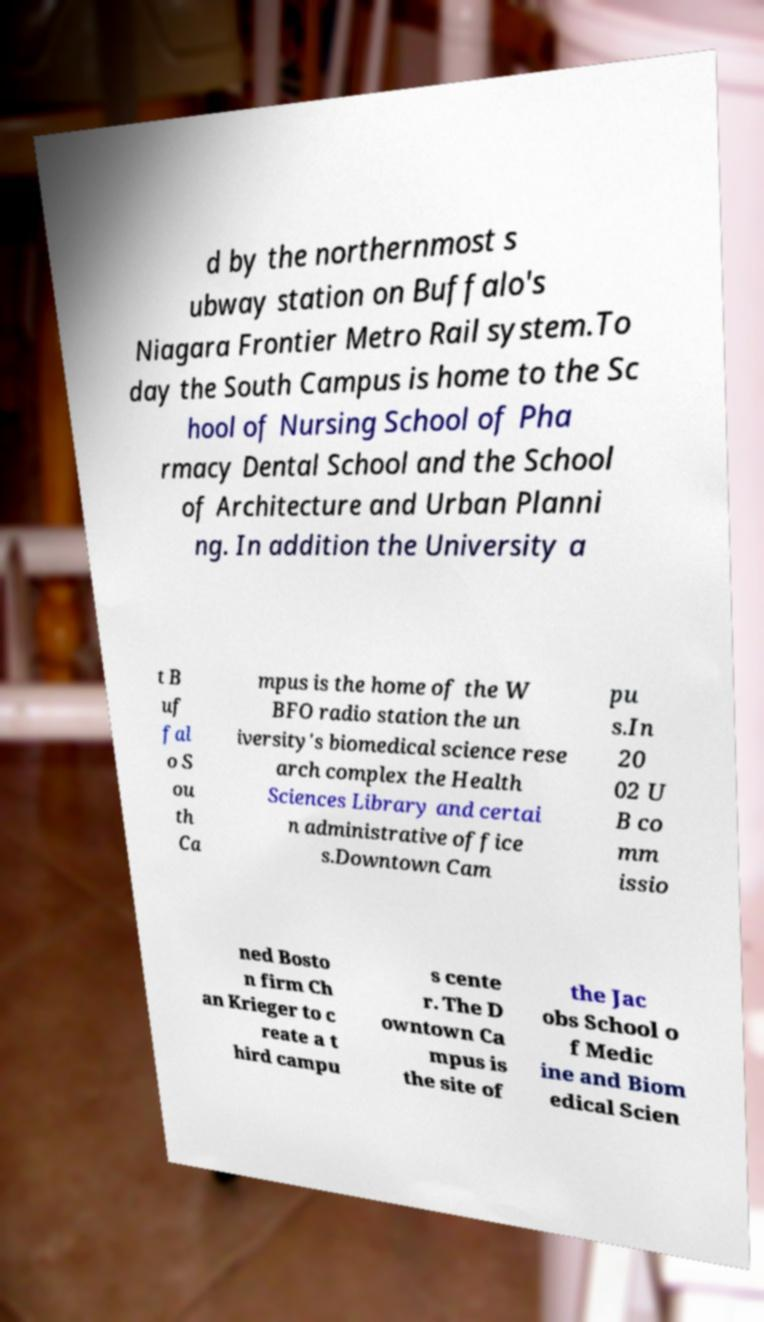Can you read and provide the text displayed in the image?This photo seems to have some interesting text. Can you extract and type it out for me? d by the northernmost s ubway station on Buffalo's Niagara Frontier Metro Rail system.To day the South Campus is home to the Sc hool of Nursing School of Pha rmacy Dental School and the School of Architecture and Urban Planni ng. In addition the University a t B uf fal o S ou th Ca mpus is the home of the W BFO radio station the un iversity's biomedical science rese arch complex the Health Sciences Library and certai n administrative office s.Downtown Cam pu s.In 20 02 U B co mm issio ned Bosto n firm Ch an Krieger to c reate a t hird campu s cente r. The D owntown Ca mpus is the site of the Jac obs School o f Medic ine and Biom edical Scien 